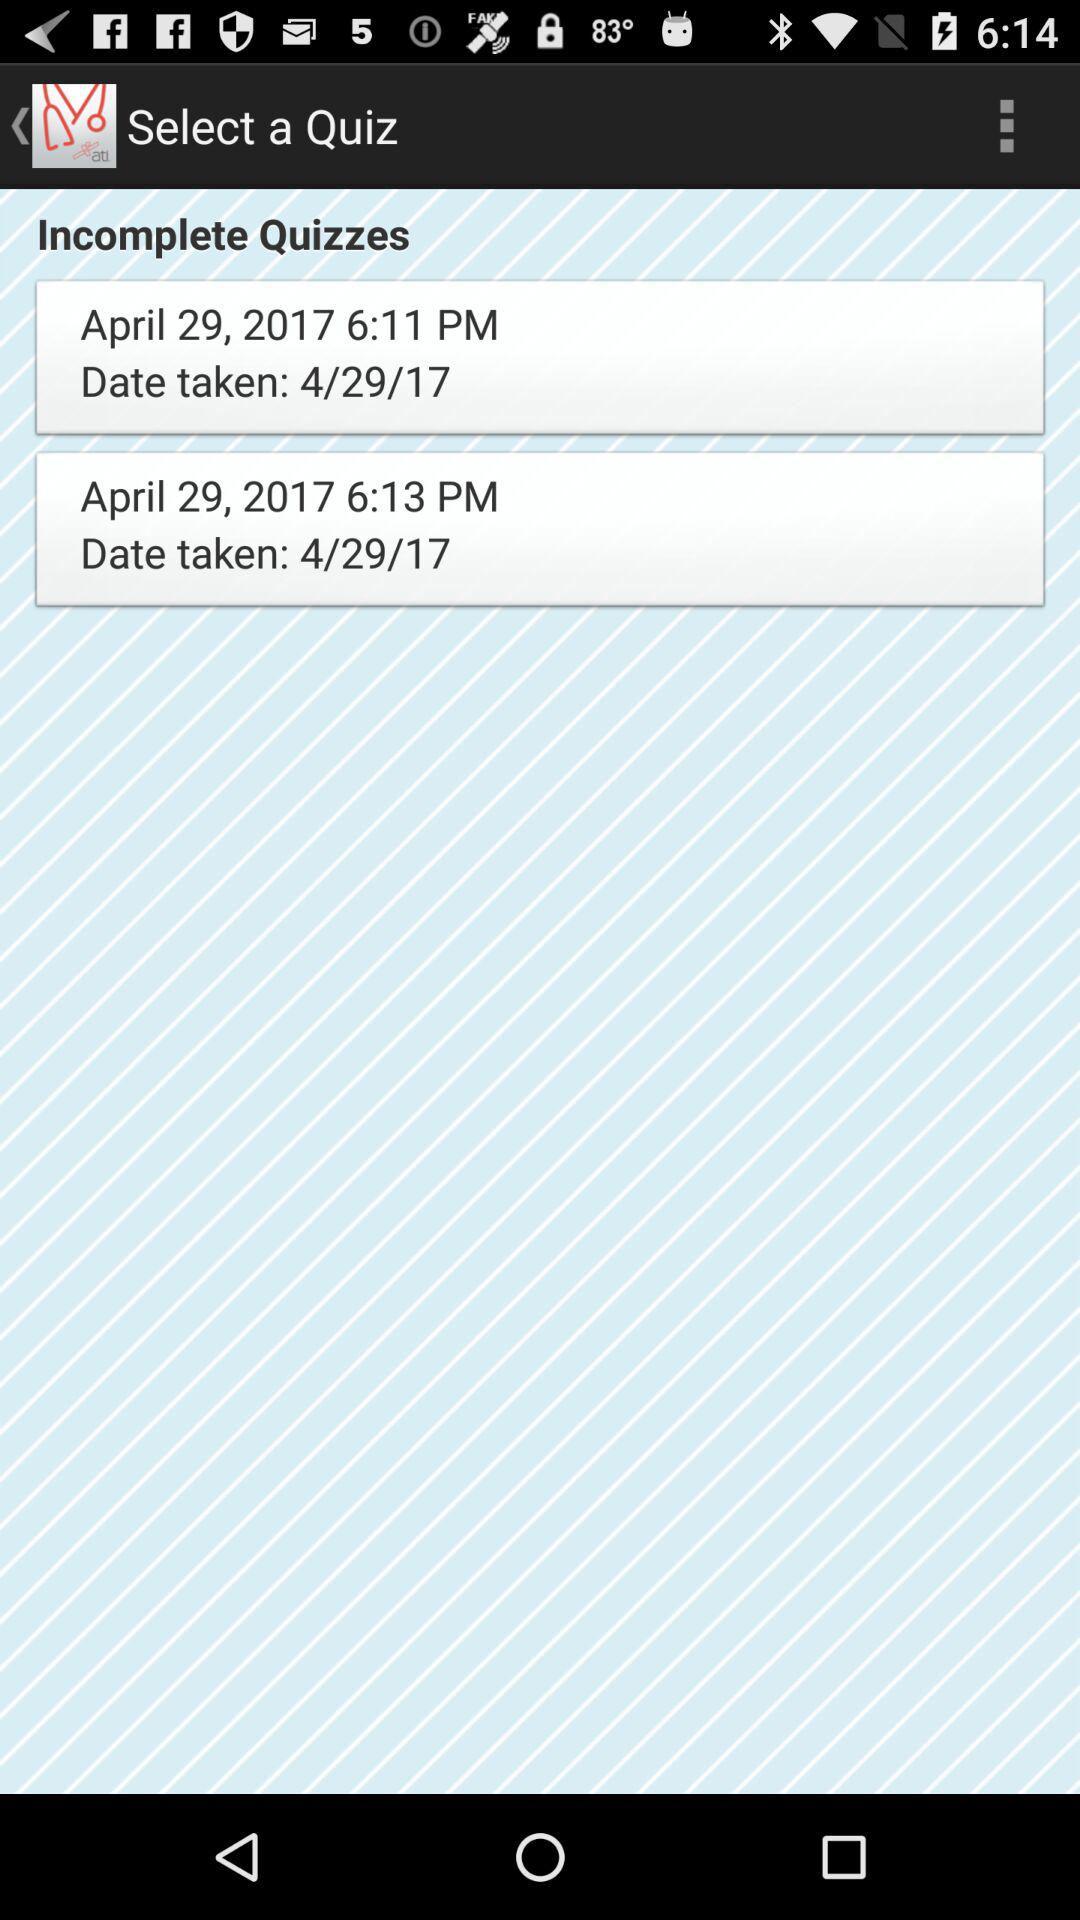How many minutes apart are the two incomplete quizzes?
Answer the question using a single word or phrase. 2 